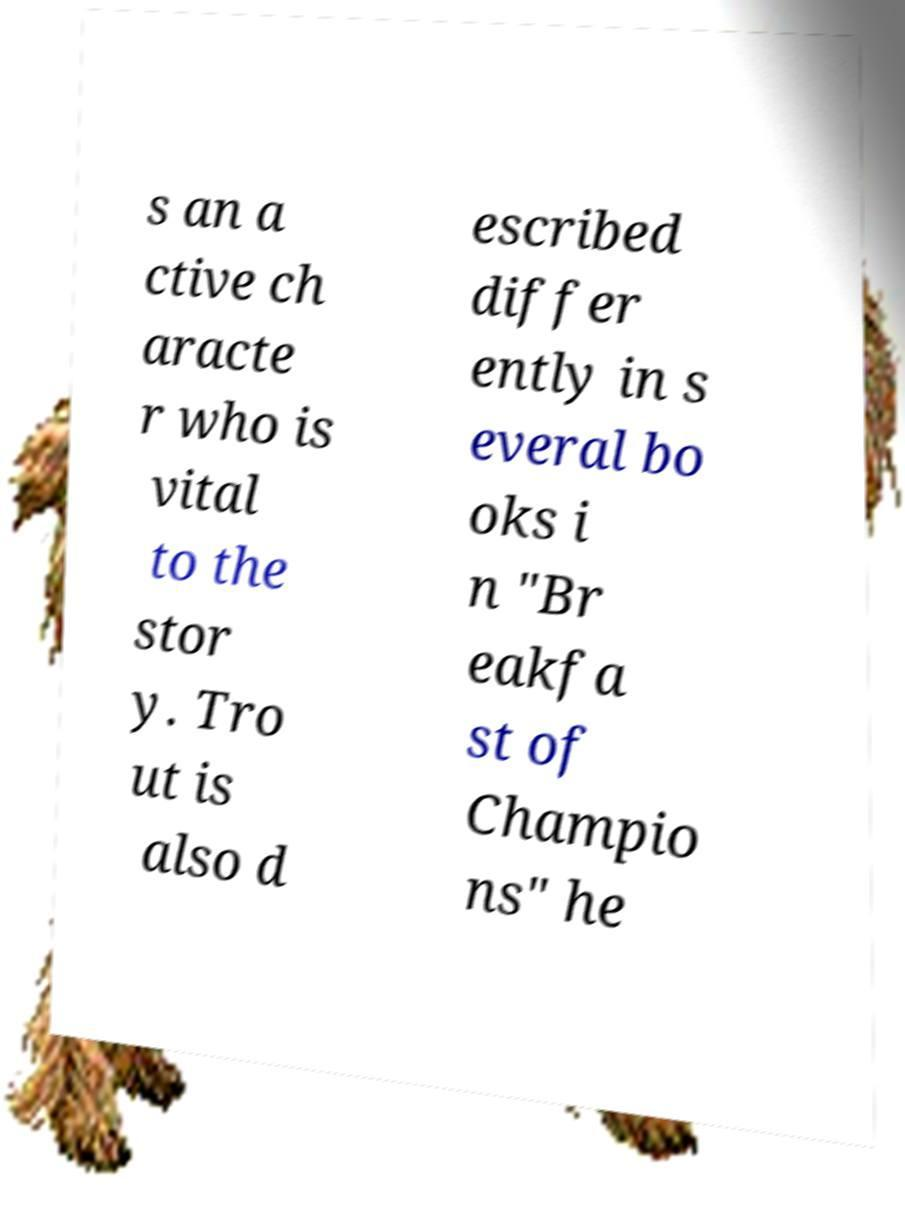There's text embedded in this image that I need extracted. Can you transcribe it verbatim? s an a ctive ch aracte r who is vital to the stor y. Tro ut is also d escribed differ ently in s everal bo oks i n "Br eakfa st of Champio ns" he 